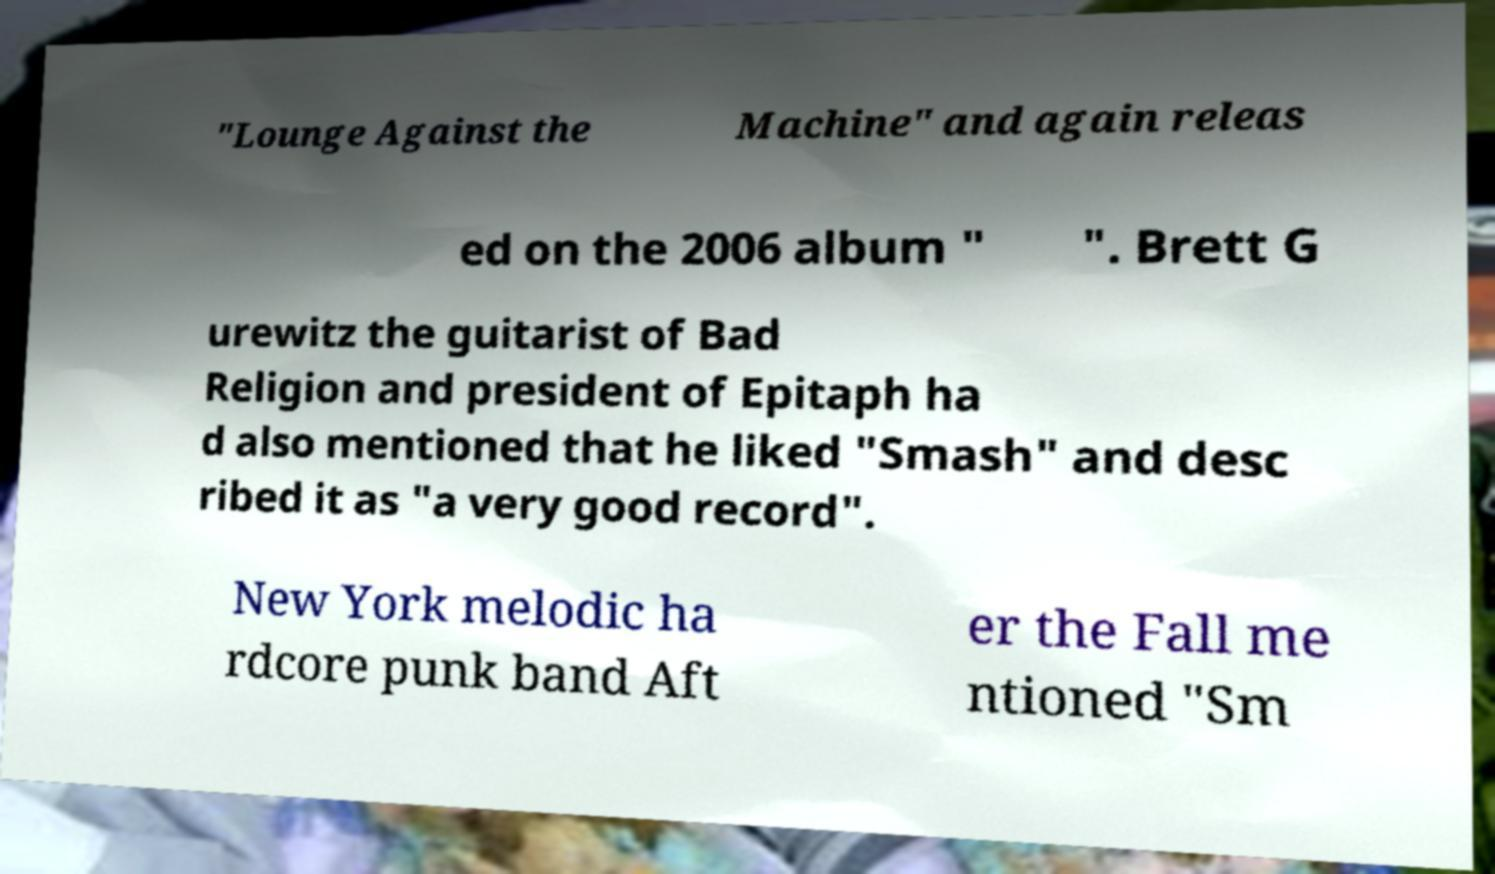I need the written content from this picture converted into text. Can you do that? "Lounge Against the Machine" and again releas ed on the 2006 album " ". Brett G urewitz the guitarist of Bad Religion and president of Epitaph ha d also mentioned that he liked "Smash" and desc ribed it as "a very good record". New York melodic ha rdcore punk band Aft er the Fall me ntioned "Sm 